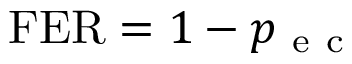<formula> <loc_0><loc_0><loc_500><loc_500>F E R = 1 - p _ { e c }</formula> 